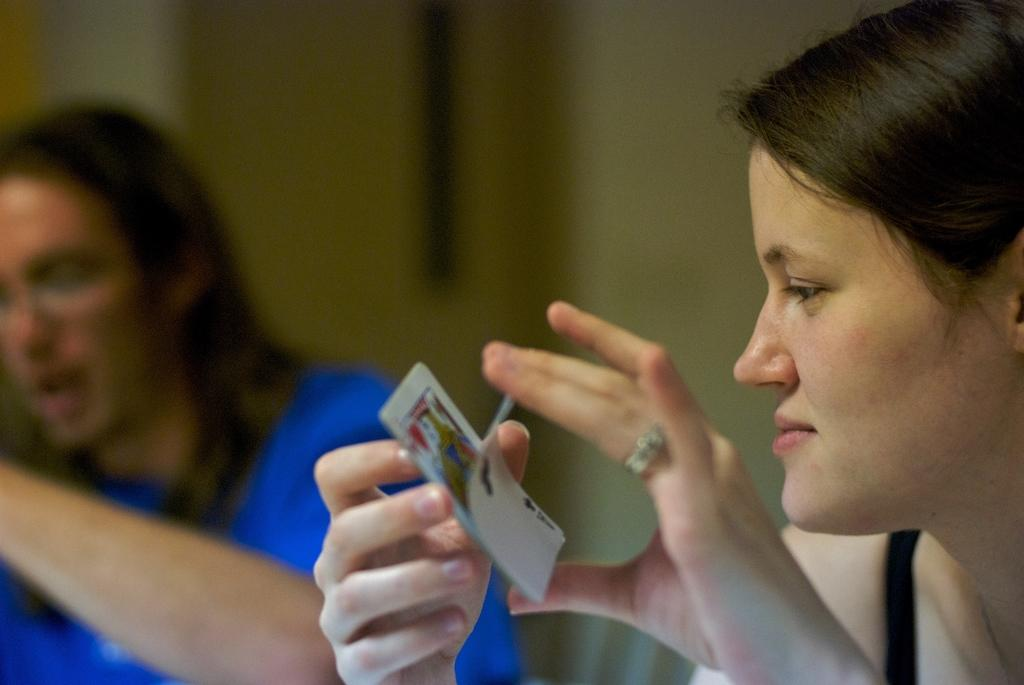How many people are present in the image? There are two people in the image, a man and a woman. What is the woman holding in the image? The woman is holding some cards. Can you describe the man in the image? The facts provided do not give any specific details about the man's appearance or actions. How much money is the man holding in the image? There is no mention of money in the image, so it cannot be determined how much the man might be holding. 